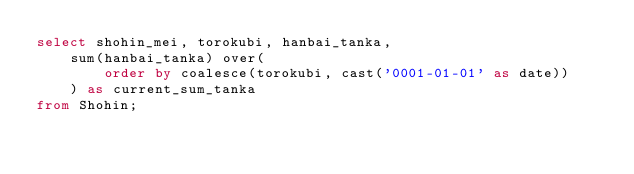<code> <loc_0><loc_0><loc_500><loc_500><_SQL_>select shohin_mei, torokubi, hanbai_tanka,
    sum(hanbai_tanka) over(
        order by coalesce(torokubi, cast('0001-01-01' as date))
    ) as current_sum_tanka
from Shohin;
</code> 